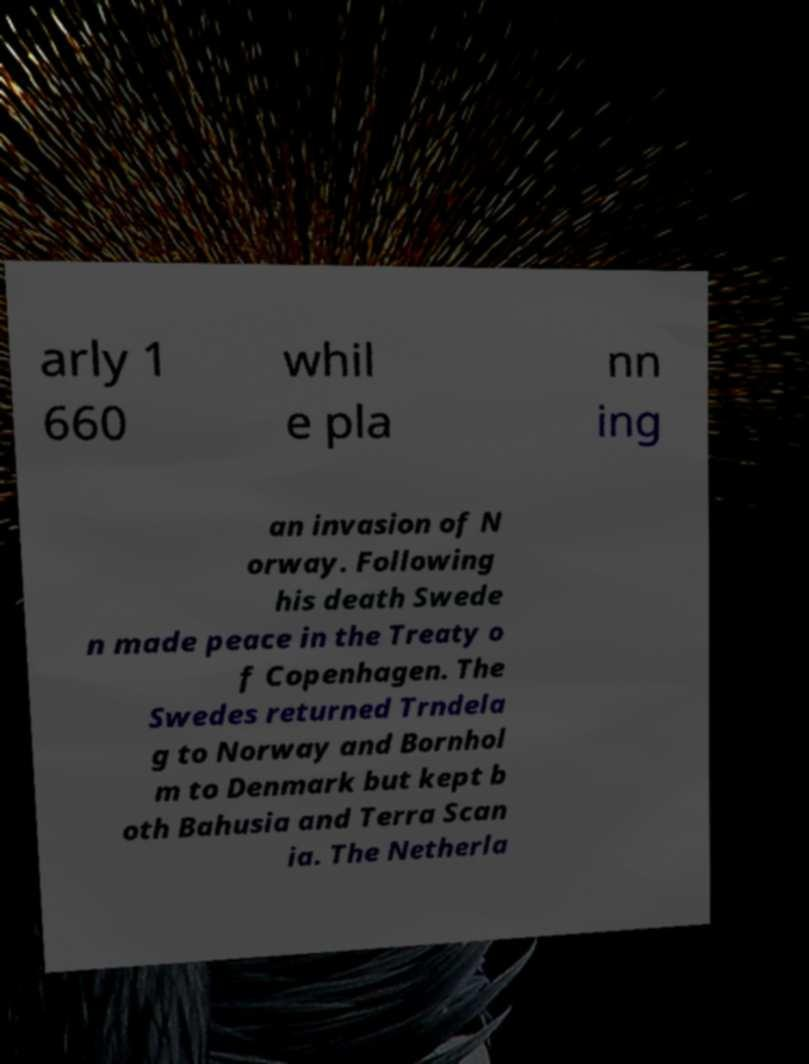Could you assist in decoding the text presented in this image and type it out clearly? arly 1 660 whil e pla nn ing an invasion of N orway. Following his death Swede n made peace in the Treaty o f Copenhagen. The Swedes returned Trndela g to Norway and Bornhol m to Denmark but kept b oth Bahusia and Terra Scan ia. The Netherla 